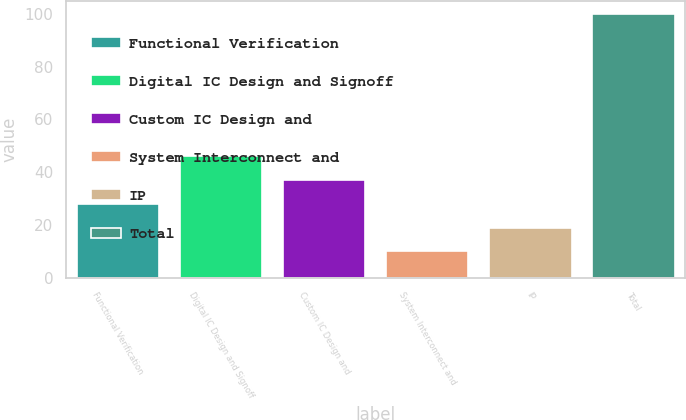Convert chart to OTSL. <chart><loc_0><loc_0><loc_500><loc_500><bar_chart><fcel>Functional Verification<fcel>Digital IC Design and Signoff<fcel>Custom IC Design and<fcel>System Interconnect and<fcel>IP<fcel>Total<nl><fcel>28<fcel>46<fcel>37<fcel>10<fcel>19<fcel>100<nl></chart> 